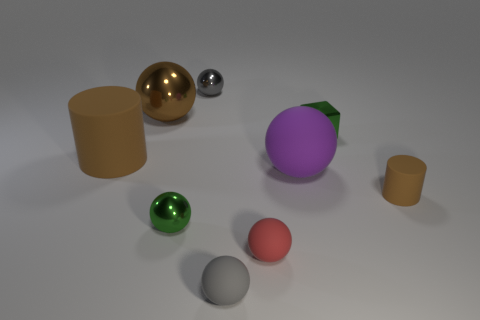What number of large rubber objects are in front of the metal sphere to the right of the green metal sphere?
Keep it short and to the point. 2. Are the brown cylinder behind the big purple ball and the small gray sphere that is behind the tiny brown rubber thing made of the same material?
Provide a succinct answer. No. What number of red things are the same shape as the brown metallic object?
Provide a short and direct response. 1. How many blocks are the same color as the small cylinder?
Offer a terse response. 0. Do the large matte object that is to the right of the big brown rubber cylinder and the brown rubber object that is behind the small rubber cylinder have the same shape?
Your answer should be compact. No. There is a matte cylinder that is on the right side of the tiny matte object that is in front of the red matte thing; what number of purple things are on the right side of it?
Your response must be concise. 0. The green object to the right of the shiny ball in front of the rubber cylinder in front of the large brown rubber cylinder is made of what material?
Make the answer very short. Metal. Are the brown cylinder to the left of the tiny brown rubber cylinder and the small brown object made of the same material?
Your response must be concise. Yes. How many other green metal balls are the same size as the green sphere?
Provide a succinct answer. 0. Is the number of red spheres that are behind the brown metallic thing greater than the number of green metal objects right of the tiny gray rubber object?
Provide a succinct answer. No. 